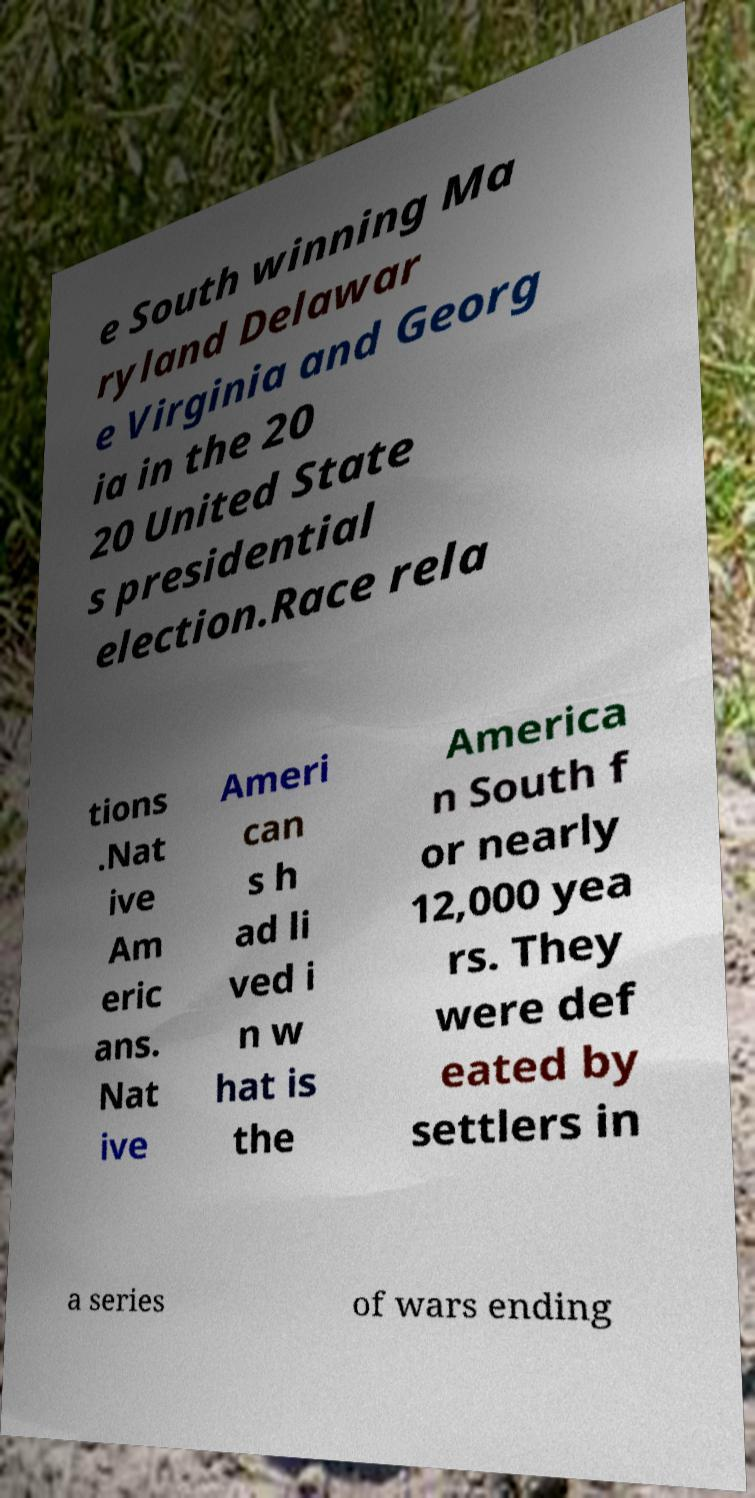What messages or text are displayed in this image? I need them in a readable, typed format. e South winning Ma ryland Delawar e Virginia and Georg ia in the 20 20 United State s presidential election.Race rela tions .Nat ive Am eric ans. Nat ive Ameri can s h ad li ved i n w hat is the America n South f or nearly 12,000 yea rs. They were def eated by settlers in a series of wars ending 